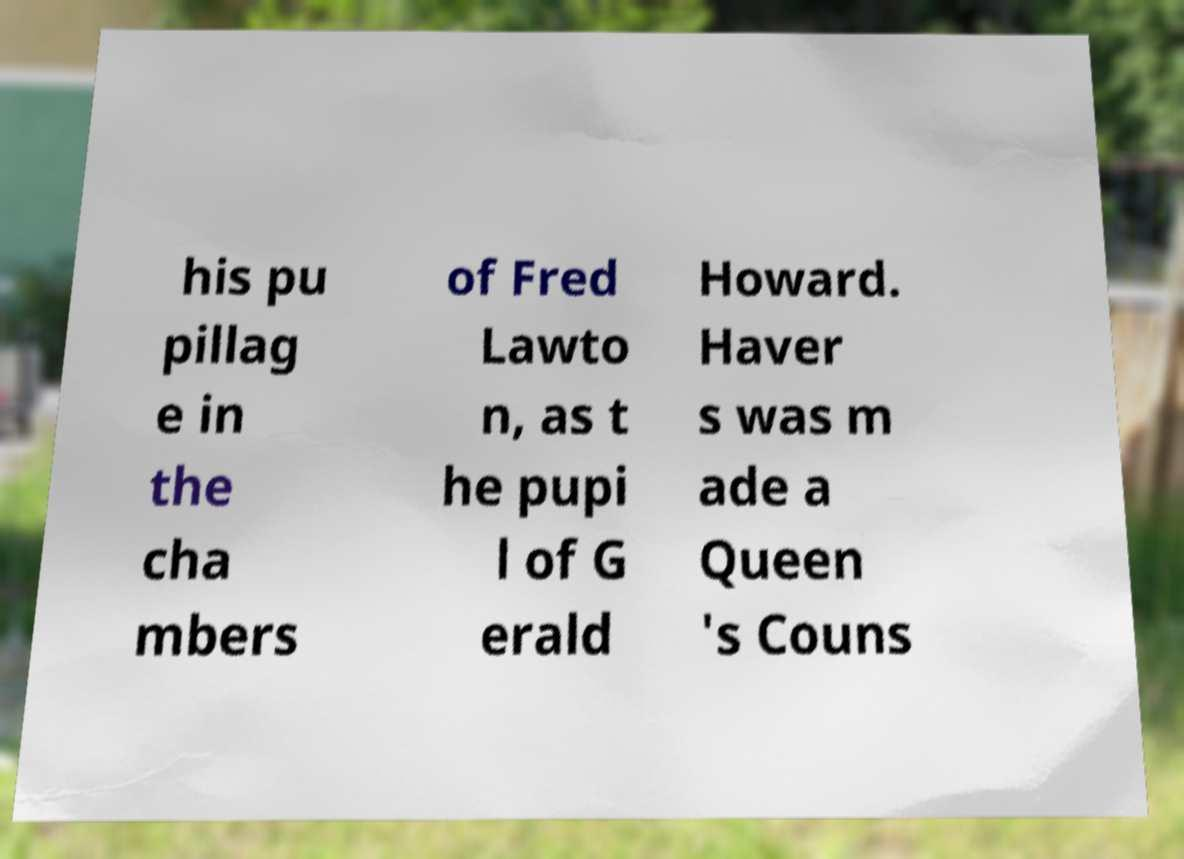Can you accurately transcribe the text from the provided image for me? his pu pillag e in the cha mbers of Fred Lawto n, as t he pupi l of G erald Howard. Haver s was m ade a Queen 's Couns 